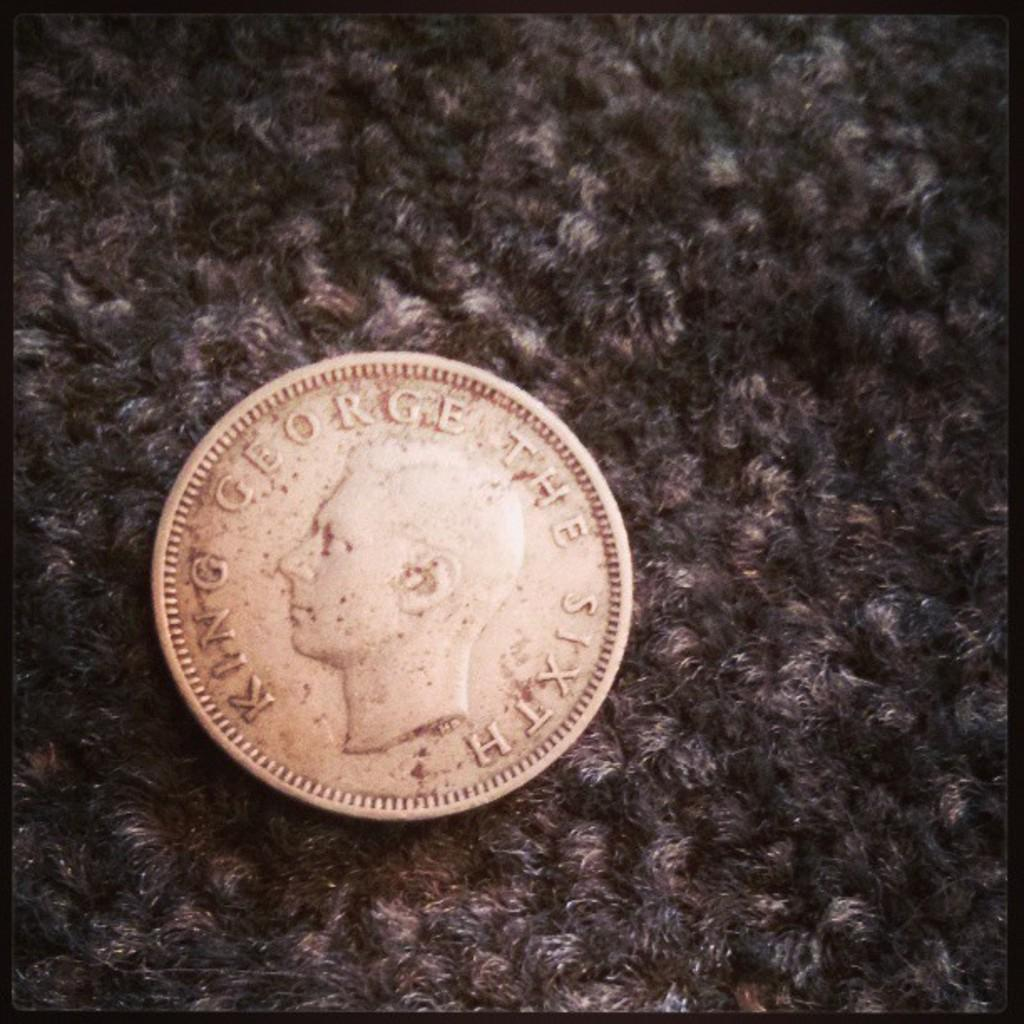<image>
Present a compact description of the photo's key features. A dime on the carpet with King George written around the edges. 